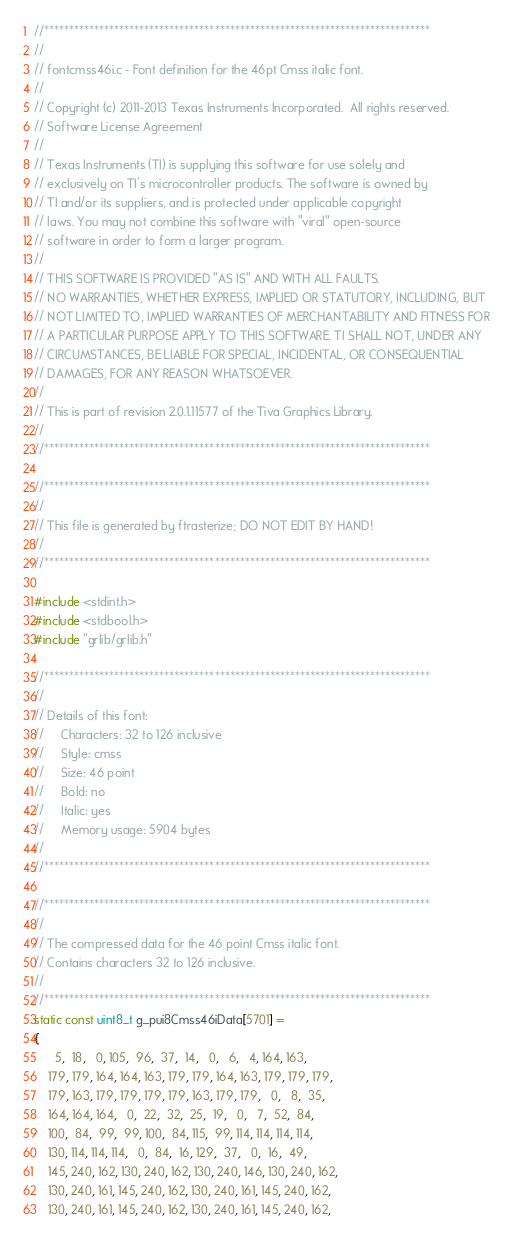<code> <loc_0><loc_0><loc_500><loc_500><_C_>//*****************************************************************************
//
// fontcmss46i.c - Font definition for the 46pt Cmss italic font.
//
// Copyright (c) 2011-2013 Texas Instruments Incorporated.  All rights reserved.
// Software License Agreement
// 
// Texas Instruments (TI) is supplying this software for use solely and
// exclusively on TI's microcontroller products. The software is owned by
// TI and/or its suppliers, and is protected under applicable copyright
// laws. You may not combine this software with "viral" open-source
// software in order to form a larger program.
// 
// THIS SOFTWARE IS PROVIDED "AS IS" AND WITH ALL FAULTS.
// NO WARRANTIES, WHETHER EXPRESS, IMPLIED OR STATUTORY, INCLUDING, BUT
// NOT LIMITED TO, IMPLIED WARRANTIES OF MERCHANTABILITY AND FITNESS FOR
// A PARTICULAR PURPOSE APPLY TO THIS SOFTWARE. TI SHALL NOT, UNDER ANY
// CIRCUMSTANCES, BE LIABLE FOR SPECIAL, INCIDENTAL, OR CONSEQUENTIAL
// DAMAGES, FOR ANY REASON WHATSOEVER.
// 
// This is part of revision 2.0.1.11577 of the Tiva Graphics Library.
//
//*****************************************************************************

//*****************************************************************************
//
// This file is generated by ftrasterize; DO NOT EDIT BY HAND!
//
//*****************************************************************************

#include <stdint.h>
#include <stdbool.h>
#include "grlib/grlib.h"

//*****************************************************************************
//
// Details of this font:
//     Characters: 32 to 126 inclusive
//     Style: cmss
//     Size: 46 point
//     Bold: no
//     Italic: yes
//     Memory usage: 5904 bytes
//
//*****************************************************************************

//*****************************************************************************
//
// The compressed data for the 46 point Cmss italic font.
// Contains characters 32 to 126 inclusive.
//
//*****************************************************************************
static const uint8_t g_pui8Cmss46iData[5701] =
{
      5,  18,   0, 105,  96,  37,  14,   0,   6,   4, 164, 163,
    179, 179, 164, 164, 163, 179, 179, 164, 163, 179, 179, 179,
    179, 163, 179, 179, 179, 179, 163, 179, 179,   0,   8,  35,
    164, 164, 164,   0,  22,  32,  25,  19,   0,   7,  52,  84,
    100,  84,  99,  99, 100,  84, 115,  99, 114, 114, 114, 114,
    130, 114, 114, 114,   0,  84,  16, 129,  37,   0,  16,  49,
    145, 240, 162, 130, 240, 162, 130, 240, 146, 130, 240, 162,
    130, 240, 161, 145, 240, 162, 130, 240, 161, 145, 240, 162,
    130, 240, 161, 145, 240, 162, 130, 240, 161, 145, 240, 162,</code> 